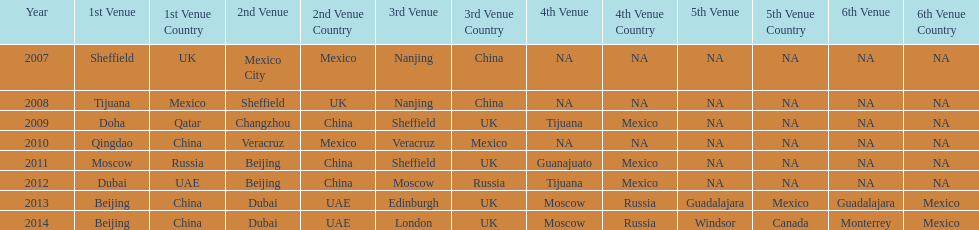What years had the most venues? 2013, 2014. Could you help me parse every detail presented in this table? {'header': ['Year', '1st Venue', '1st Venue Country', '2nd Venue', '2nd Venue Country', '3rd Venue', '3rd Venue Country', '4th Venue', '4th Venue Country', '5th Venue', '5th Venue Country', '6th Venue', '6th Venue Country'], 'rows': [['2007', 'Sheffield', 'UK', 'Mexico City', 'Mexico', 'Nanjing', 'China', 'NA', 'NA', 'NA', 'NA', 'NA', 'NA'], ['2008', 'Tijuana', 'Mexico', 'Sheffield', 'UK', 'Nanjing', 'China', 'NA', 'NA', 'NA', 'NA', 'NA', 'NA'], ['2009', 'Doha', 'Qatar', 'Changzhou', 'China', 'Sheffield', 'UK', 'Tijuana', 'Mexico', 'NA', 'NA', 'NA', 'NA'], ['2010', 'Qingdao', 'China', 'Veracruz', 'Mexico', 'Veracruz', 'Mexico', 'NA', 'NA', 'NA', 'NA', 'NA', 'NA'], ['2011', 'Moscow', 'Russia', 'Beijing', 'China', 'Sheffield', 'UK', 'Guanajuato', 'Mexico', 'NA', 'NA', 'NA', 'NA'], ['2012', 'Dubai', 'UAE', 'Beijing', 'China', 'Moscow', 'Russia', 'Tijuana', 'Mexico', 'NA', 'NA', 'NA', 'NA'], ['2013', 'Beijing', 'China', 'Dubai', 'UAE', 'Edinburgh', 'UK', 'Moscow', 'Russia', 'Guadalajara', 'Mexico', 'Guadalajara', 'Mexico'], ['2014', 'Beijing', 'China', 'Dubai', 'UAE', 'London', 'UK', 'Moscow', 'Russia', 'Windsor', 'Canada', 'Monterrey', 'Mexico']]} 